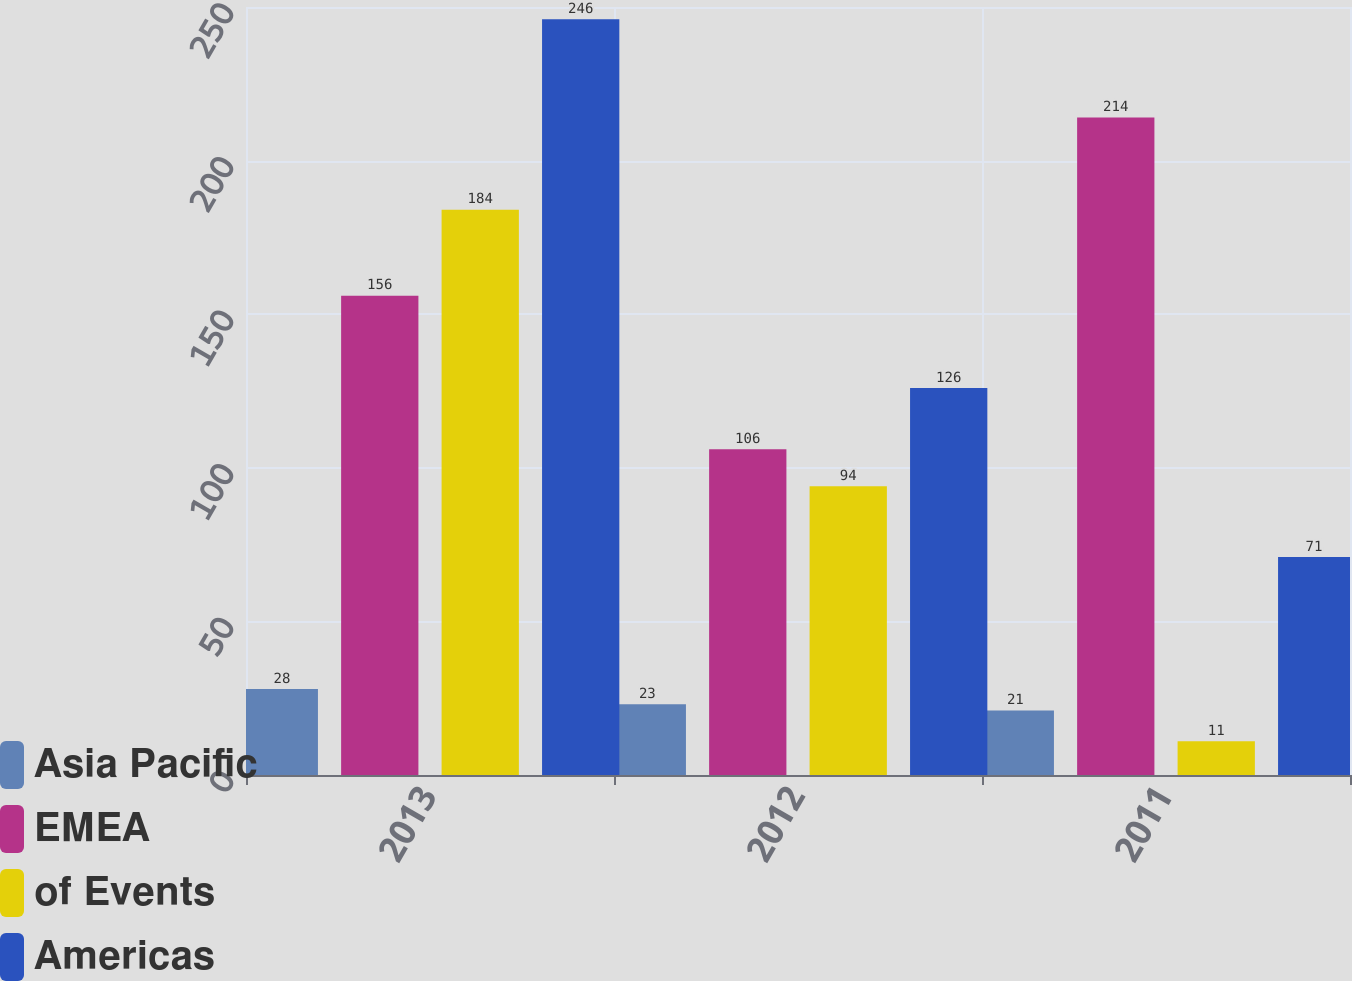<chart> <loc_0><loc_0><loc_500><loc_500><stacked_bar_chart><ecel><fcel>2013<fcel>2012<fcel>2011<nl><fcel>Asia Pacific<fcel>28<fcel>23<fcel>21<nl><fcel>EMEA<fcel>156<fcel>106<fcel>214<nl><fcel>of Events<fcel>184<fcel>94<fcel>11<nl><fcel>Americas<fcel>246<fcel>126<fcel>71<nl></chart> 